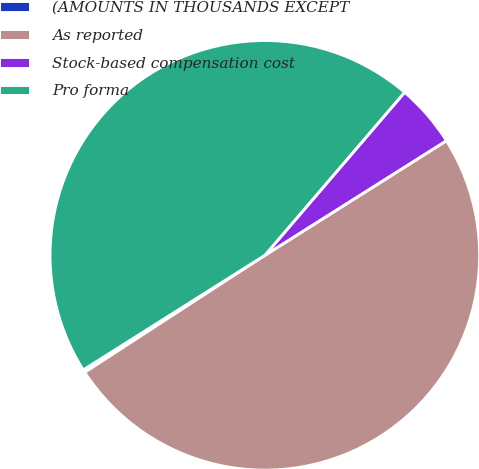Convert chart to OTSL. <chart><loc_0><loc_0><loc_500><loc_500><pie_chart><fcel>(AMOUNTS IN THOUSANDS EXCEPT<fcel>As reported<fcel>Stock-based compensation cost<fcel>Pro forma<nl><fcel>0.21%<fcel>49.79%<fcel>4.76%<fcel>45.24%<nl></chart> 